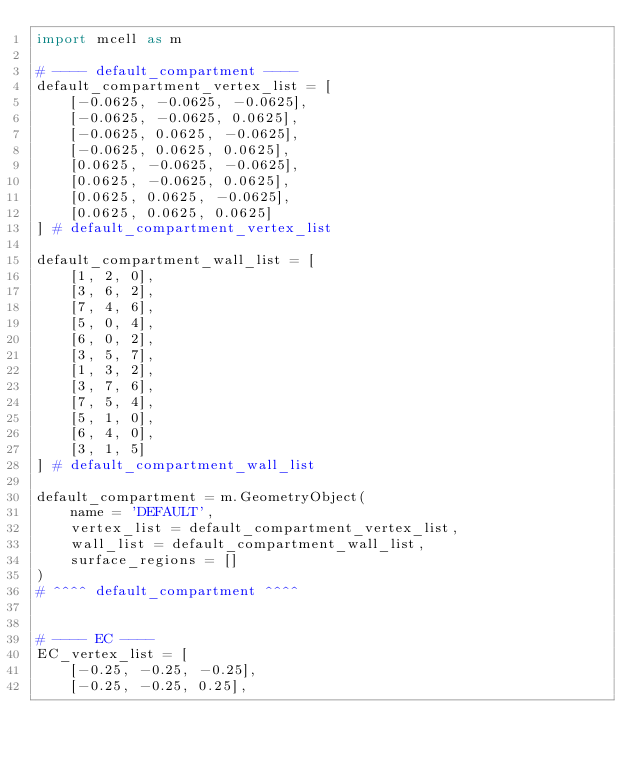Convert code to text. <code><loc_0><loc_0><loc_500><loc_500><_Python_>import mcell as m

# ---- default_compartment ----
default_compartment_vertex_list = [
    [-0.0625, -0.0625, -0.0625], 
    [-0.0625, -0.0625, 0.0625], 
    [-0.0625, 0.0625, -0.0625], 
    [-0.0625, 0.0625, 0.0625], 
    [0.0625, -0.0625, -0.0625], 
    [0.0625, -0.0625, 0.0625], 
    [0.0625, 0.0625, -0.0625], 
    [0.0625, 0.0625, 0.0625]
] # default_compartment_vertex_list

default_compartment_wall_list = [
    [1, 2, 0], 
    [3, 6, 2], 
    [7, 4, 6], 
    [5, 0, 4], 
    [6, 0, 2], 
    [3, 5, 7], 
    [1, 3, 2], 
    [3, 7, 6], 
    [7, 5, 4], 
    [5, 1, 0], 
    [6, 4, 0], 
    [3, 1, 5]
] # default_compartment_wall_list

default_compartment = m.GeometryObject(
    name = 'DEFAULT',
    vertex_list = default_compartment_vertex_list,
    wall_list = default_compartment_wall_list,
    surface_regions = []
)
# ^^^^ default_compartment ^^^^


# ---- EC ----
EC_vertex_list = [
    [-0.25, -0.25, -0.25], 
    [-0.25, -0.25, 0.25], </code> 